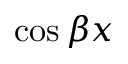<formula> <loc_0><loc_0><loc_500><loc_500>\cos { \beta x }</formula> 